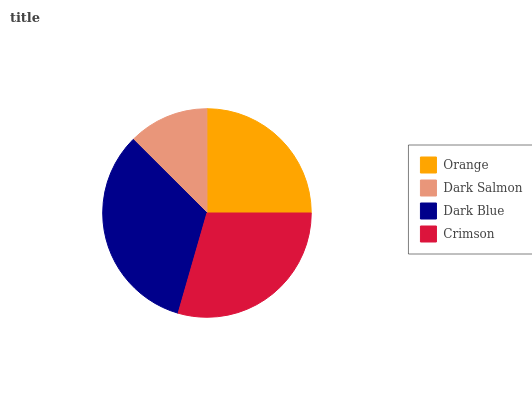Is Dark Salmon the minimum?
Answer yes or no. Yes. Is Dark Blue the maximum?
Answer yes or no. Yes. Is Dark Blue the minimum?
Answer yes or no. No. Is Dark Salmon the maximum?
Answer yes or no. No. Is Dark Blue greater than Dark Salmon?
Answer yes or no. Yes. Is Dark Salmon less than Dark Blue?
Answer yes or no. Yes. Is Dark Salmon greater than Dark Blue?
Answer yes or no. No. Is Dark Blue less than Dark Salmon?
Answer yes or no. No. Is Crimson the high median?
Answer yes or no. Yes. Is Orange the low median?
Answer yes or no. Yes. Is Dark Blue the high median?
Answer yes or no. No. Is Crimson the low median?
Answer yes or no. No. 